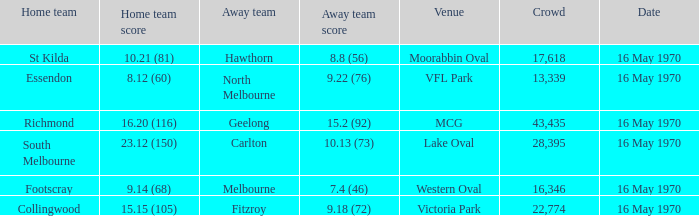What did the away team score when the home team was south melbourne? 10.13 (73). 